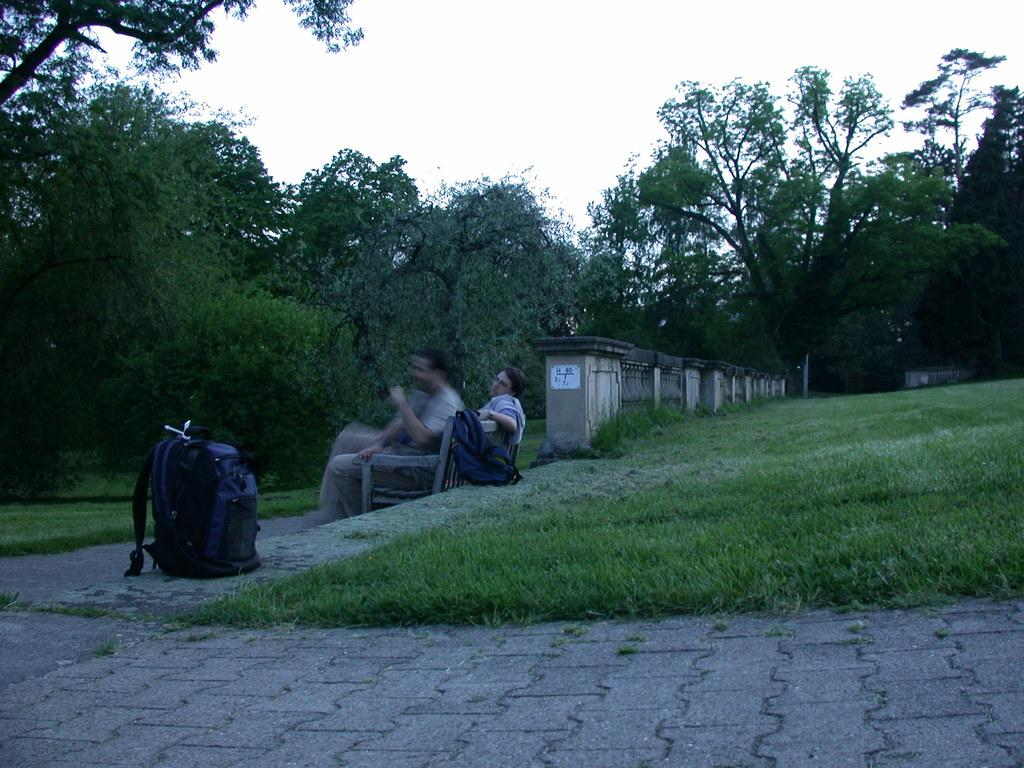What are the two men in the image doing? The two men are sitting on a bench in the image. What can be seen in the background of the image? There are trees around the bench in the image. What type of vegetation is on the right side of the image? There is grass on the right side of the image. What object is on the left side of the image? There is a bag on the left side of the image. Can you see a sail in the image? There is no sail present in the image. Is there a road visible in the image? There is no road visible in the image. 